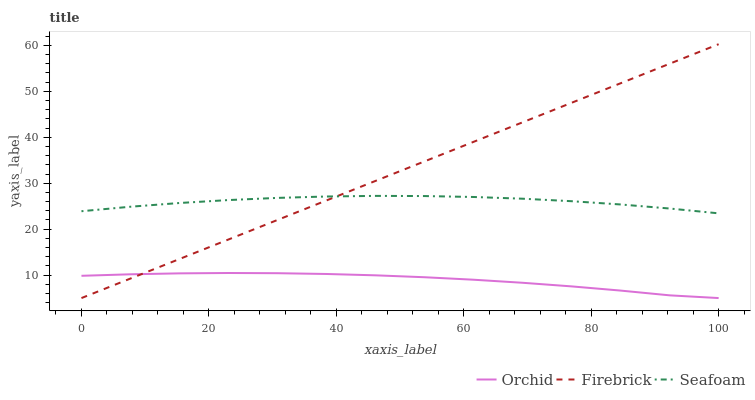Does Orchid have the minimum area under the curve?
Answer yes or no. Yes. Does Firebrick have the maximum area under the curve?
Answer yes or no. Yes. Does Seafoam have the minimum area under the curve?
Answer yes or no. No. Does Seafoam have the maximum area under the curve?
Answer yes or no. No. Is Firebrick the smoothest?
Answer yes or no. Yes. Is Seafoam the roughest?
Answer yes or no. Yes. Is Orchid the smoothest?
Answer yes or no. No. Is Orchid the roughest?
Answer yes or no. No. Does Firebrick have the lowest value?
Answer yes or no. Yes. Does Seafoam have the lowest value?
Answer yes or no. No. Does Firebrick have the highest value?
Answer yes or no. Yes. Does Seafoam have the highest value?
Answer yes or no. No. Is Orchid less than Seafoam?
Answer yes or no. Yes. Is Seafoam greater than Orchid?
Answer yes or no. Yes. Does Orchid intersect Firebrick?
Answer yes or no. Yes. Is Orchid less than Firebrick?
Answer yes or no. No. Is Orchid greater than Firebrick?
Answer yes or no. No. Does Orchid intersect Seafoam?
Answer yes or no. No. 